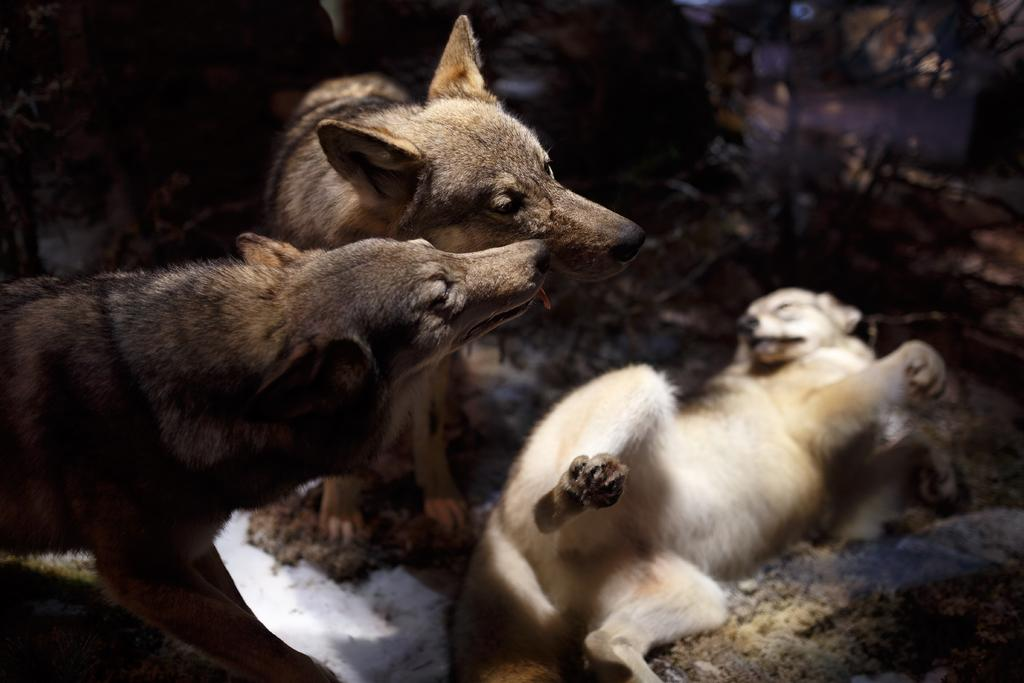What is located in the front of the image? There are animals in the front of the image. What can be seen in the background of the image? There are trees in the background of the image. Where is the mailbox located in the image? There is no mailbox present in the image. What type of help can be seen being provided to the animals in the image? There is no indication of help being provided to the animals in the image. 